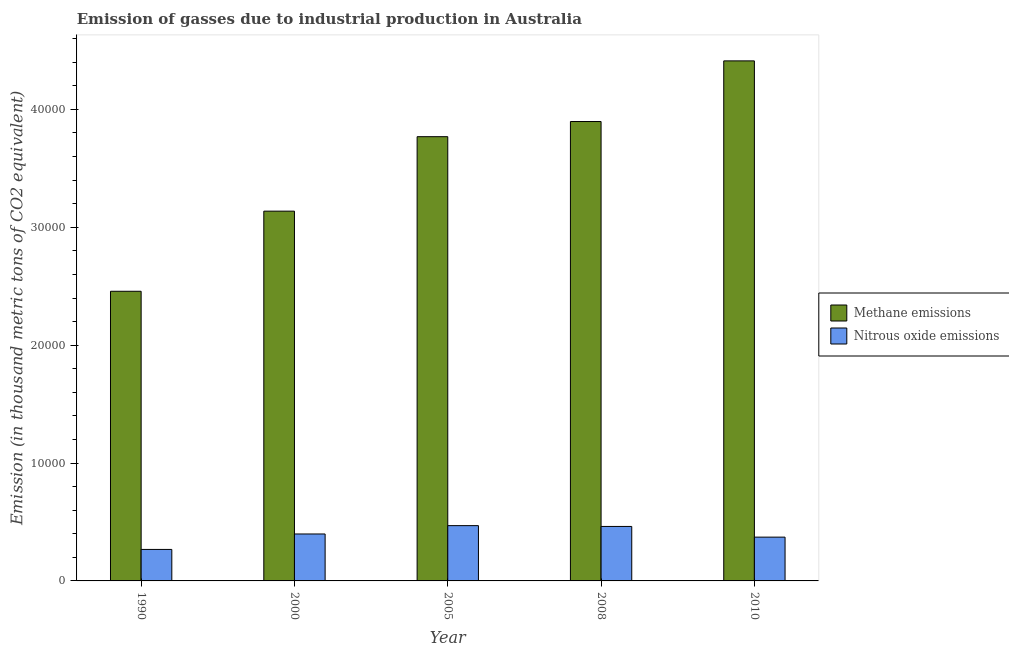How many different coloured bars are there?
Make the answer very short. 2. How many groups of bars are there?
Offer a terse response. 5. What is the label of the 3rd group of bars from the left?
Offer a terse response. 2005. In how many cases, is the number of bars for a given year not equal to the number of legend labels?
Offer a very short reply. 0. What is the amount of nitrous oxide emissions in 2008?
Your answer should be compact. 4621. Across all years, what is the maximum amount of nitrous oxide emissions?
Make the answer very short. 4690.1. Across all years, what is the minimum amount of nitrous oxide emissions?
Keep it short and to the point. 2671. In which year was the amount of nitrous oxide emissions maximum?
Provide a short and direct response. 2005. In which year was the amount of methane emissions minimum?
Give a very brief answer. 1990. What is the total amount of nitrous oxide emissions in the graph?
Offer a terse response. 1.97e+04. What is the difference between the amount of methane emissions in 1990 and that in 2010?
Provide a short and direct response. -1.95e+04. What is the difference between the amount of methane emissions in 1990 and the amount of nitrous oxide emissions in 2010?
Keep it short and to the point. -1.95e+04. What is the average amount of nitrous oxide emissions per year?
Provide a short and direct response. 3935.56. What is the ratio of the amount of nitrous oxide emissions in 1990 to that in 2010?
Make the answer very short. 0.72. Is the difference between the amount of nitrous oxide emissions in 2000 and 2005 greater than the difference between the amount of methane emissions in 2000 and 2005?
Your answer should be very brief. No. What is the difference between the highest and the second highest amount of nitrous oxide emissions?
Provide a succinct answer. 69.1. What is the difference between the highest and the lowest amount of methane emissions?
Offer a terse response. 1.95e+04. Is the sum of the amount of nitrous oxide emissions in 1990 and 2008 greater than the maximum amount of methane emissions across all years?
Keep it short and to the point. Yes. What does the 1st bar from the left in 1990 represents?
Provide a succinct answer. Methane emissions. What does the 1st bar from the right in 2005 represents?
Your response must be concise. Nitrous oxide emissions. How many years are there in the graph?
Give a very brief answer. 5. What is the difference between two consecutive major ticks on the Y-axis?
Provide a short and direct response. 10000. Are the values on the major ticks of Y-axis written in scientific E-notation?
Provide a short and direct response. No. Does the graph contain grids?
Provide a succinct answer. No. Where does the legend appear in the graph?
Your response must be concise. Center right. How many legend labels are there?
Make the answer very short. 2. How are the legend labels stacked?
Offer a very short reply. Vertical. What is the title of the graph?
Make the answer very short. Emission of gasses due to industrial production in Australia. What is the label or title of the Y-axis?
Provide a short and direct response. Emission (in thousand metric tons of CO2 equivalent). What is the Emission (in thousand metric tons of CO2 equivalent) in Methane emissions in 1990?
Offer a very short reply. 2.46e+04. What is the Emission (in thousand metric tons of CO2 equivalent) in Nitrous oxide emissions in 1990?
Ensure brevity in your answer.  2671. What is the Emission (in thousand metric tons of CO2 equivalent) of Methane emissions in 2000?
Offer a terse response. 3.14e+04. What is the Emission (in thousand metric tons of CO2 equivalent) of Nitrous oxide emissions in 2000?
Make the answer very short. 3981.7. What is the Emission (in thousand metric tons of CO2 equivalent) in Methane emissions in 2005?
Your answer should be compact. 3.77e+04. What is the Emission (in thousand metric tons of CO2 equivalent) in Nitrous oxide emissions in 2005?
Offer a very short reply. 4690.1. What is the Emission (in thousand metric tons of CO2 equivalent) of Methane emissions in 2008?
Offer a very short reply. 3.90e+04. What is the Emission (in thousand metric tons of CO2 equivalent) of Nitrous oxide emissions in 2008?
Your answer should be compact. 4621. What is the Emission (in thousand metric tons of CO2 equivalent) in Methane emissions in 2010?
Provide a succinct answer. 4.41e+04. What is the Emission (in thousand metric tons of CO2 equivalent) of Nitrous oxide emissions in 2010?
Your response must be concise. 3714. Across all years, what is the maximum Emission (in thousand metric tons of CO2 equivalent) of Methane emissions?
Your answer should be compact. 4.41e+04. Across all years, what is the maximum Emission (in thousand metric tons of CO2 equivalent) in Nitrous oxide emissions?
Provide a succinct answer. 4690.1. Across all years, what is the minimum Emission (in thousand metric tons of CO2 equivalent) of Methane emissions?
Provide a short and direct response. 2.46e+04. Across all years, what is the minimum Emission (in thousand metric tons of CO2 equivalent) in Nitrous oxide emissions?
Make the answer very short. 2671. What is the total Emission (in thousand metric tons of CO2 equivalent) in Methane emissions in the graph?
Provide a succinct answer. 1.77e+05. What is the total Emission (in thousand metric tons of CO2 equivalent) in Nitrous oxide emissions in the graph?
Keep it short and to the point. 1.97e+04. What is the difference between the Emission (in thousand metric tons of CO2 equivalent) of Methane emissions in 1990 and that in 2000?
Your answer should be compact. -6797.8. What is the difference between the Emission (in thousand metric tons of CO2 equivalent) in Nitrous oxide emissions in 1990 and that in 2000?
Your answer should be very brief. -1310.7. What is the difference between the Emission (in thousand metric tons of CO2 equivalent) in Methane emissions in 1990 and that in 2005?
Provide a succinct answer. -1.31e+04. What is the difference between the Emission (in thousand metric tons of CO2 equivalent) of Nitrous oxide emissions in 1990 and that in 2005?
Your response must be concise. -2019.1. What is the difference between the Emission (in thousand metric tons of CO2 equivalent) in Methane emissions in 1990 and that in 2008?
Your answer should be very brief. -1.44e+04. What is the difference between the Emission (in thousand metric tons of CO2 equivalent) of Nitrous oxide emissions in 1990 and that in 2008?
Your answer should be compact. -1950. What is the difference between the Emission (in thousand metric tons of CO2 equivalent) in Methane emissions in 1990 and that in 2010?
Your answer should be very brief. -1.95e+04. What is the difference between the Emission (in thousand metric tons of CO2 equivalent) in Nitrous oxide emissions in 1990 and that in 2010?
Provide a short and direct response. -1043. What is the difference between the Emission (in thousand metric tons of CO2 equivalent) in Methane emissions in 2000 and that in 2005?
Provide a succinct answer. -6316.4. What is the difference between the Emission (in thousand metric tons of CO2 equivalent) in Nitrous oxide emissions in 2000 and that in 2005?
Make the answer very short. -708.4. What is the difference between the Emission (in thousand metric tons of CO2 equivalent) of Methane emissions in 2000 and that in 2008?
Offer a terse response. -7602.4. What is the difference between the Emission (in thousand metric tons of CO2 equivalent) of Nitrous oxide emissions in 2000 and that in 2008?
Provide a short and direct response. -639.3. What is the difference between the Emission (in thousand metric tons of CO2 equivalent) of Methane emissions in 2000 and that in 2010?
Provide a short and direct response. -1.27e+04. What is the difference between the Emission (in thousand metric tons of CO2 equivalent) of Nitrous oxide emissions in 2000 and that in 2010?
Offer a terse response. 267.7. What is the difference between the Emission (in thousand metric tons of CO2 equivalent) of Methane emissions in 2005 and that in 2008?
Keep it short and to the point. -1286. What is the difference between the Emission (in thousand metric tons of CO2 equivalent) of Nitrous oxide emissions in 2005 and that in 2008?
Keep it short and to the point. 69.1. What is the difference between the Emission (in thousand metric tons of CO2 equivalent) of Methane emissions in 2005 and that in 2010?
Provide a succinct answer. -6430.6. What is the difference between the Emission (in thousand metric tons of CO2 equivalent) in Nitrous oxide emissions in 2005 and that in 2010?
Make the answer very short. 976.1. What is the difference between the Emission (in thousand metric tons of CO2 equivalent) of Methane emissions in 2008 and that in 2010?
Offer a terse response. -5144.6. What is the difference between the Emission (in thousand metric tons of CO2 equivalent) of Nitrous oxide emissions in 2008 and that in 2010?
Your answer should be compact. 907. What is the difference between the Emission (in thousand metric tons of CO2 equivalent) in Methane emissions in 1990 and the Emission (in thousand metric tons of CO2 equivalent) in Nitrous oxide emissions in 2000?
Provide a short and direct response. 2.06e+04. What is the difference between the Emission (in thousand metric tons of CO2 equivalent) in Methane emissions in 1990 and the Emission (in thousand metric tons of CO2 equivalent) in Nitrous oxide emissions in 2005?
Keep it short and to the point. 1.99e+04. What is the difference between the Emission (in thousand metric tons of CO2 equivalent) of Methane emissions in 1990 and the Emission (in thousand metric tons of CO2 equivalent) of Nitrous oxide emissions in 2008?
Your answer should be compact. 1.99e+04. What is the difference between the Emission (in thousand metric tons of CO2 equivalent) of Methane emissions in 1990 and the Emission (in thousand metric tons of CO2 equivalent) of Nitrous oxide emissions in 2010?
Offer a very short reply. 2.09e+04. What is the difference between the Emission (in thousand metric tons of CO2 equivalent) of Methane emissions in 2000 and the Emission (in thousand metric tons of CO2 equivalent) of Nitrous oxide emissions in 2005?
Ensure brevity in your answer.  2.67e+04. What is the difference between the Emission (in thousand metric tons of CO2 equivalent) of Methane emissions in 2000 and the Emission (in thousand metric tons of CO2 equivalent) of Nitrous oxide emissions in 2008?
Your answer should be compact. 2.67e+04. What is the difference between the Emission (in thousand metric tons of CO2 equivalent) of Methane emissions in 2000 and the Emission (in thousand metric tons of CO2 equivalent) of Nitrous oxide emissions in 2010?
Ensure brevity in your answer.  2.77e+04. What is the difference between the Emission (in thousand metric tons of CO2 equivalent) in Methane emissions in 2005 and the Emission (in thousand metric tons of CO2 equivalent) in Nitrous oxide emissions in 2008?
Provide a succinct answer. 3.31e+04. What is the difference between the Emission (in thousand metric tons of CO2 equivalent) in Methane emissions in 2005 and the Emission (in thousand metric tons of CO2 equivalent) in Nitrous oxide emissions in 2010?
Your answer should be compact. 3.40e+04. What is the difference between the Emission (in thousand metric tons of CO2 equivalent) in Methane emissions in 2008 and the Emission (in thousand metric tons of CO2 equivalent) in Nitrous oxide emissions in 2010?
Offer a very short reply. 3.53e+04. What is the average Emission (in thousand metric tons of CO2 equivalent) in Methane emissions per year?
Provide a succinct answer. 3.53e+04. What is the average Emission (in thousand metric tons of CO2 equivalent) in Nitrous oxide emissions per year?
Keep it short and to the point. 3935.56. In the year 1990, what is the difference between the Emission (in thousand metric tons of CO2 equivalent) in Methane emissions and Emission (in thousand metric tons of CO2 equivalent) in Nitrous oxide emissions?
Provide a succinct answer. 2.19e+04. In the year 2000, what is the difference between the Emission (in thousand metric tons of CO2 equivalent) of Methane emissions and Emission (in thousand metric tons of CO2 equivalent) of Nitrous oxide emissions?
Provide a short and direct response. 2.74e+04. In the year 2005, what is the difference between the Emission (in thousand metric tons of CO2 equivalent) of Methane emissions and Emission (in thousand metric tons of CO2 equivalent) of Nitrous oxide emissions?
Provide a short and direct response. 3.30e+04. In the year 2008, what is the difference between the Emission (in thousand metric tons of CO2 equivalent) of Methane emissions and Emission (in thousand metric tons of CO2 equivalent) of Nitrous oxide emissions?
Ensure brevity in your answer.  3.43e+04. In the year 2010, what is the difference between the Emission (in thousand metric tons of CO2 equivalent) in Methane emissions and Emission (in thousand metric tons of CO2 equivalent) in Nitrous oxide emissions?
Keep it short and to the point. 4.04e+04. What is the ratio of the Emission (in thousand metric tons of CO2 equivalent) of Methane emissions in 1990 to that in 2000?
Provide a succinct answer. 0.78. What is the ratio of the Emission (in thousand metric tons of CO2 equivalent) of Nitrous oxide emissions in 1990 to that in 2000?
Keep it short and to the point. 0.67. What is the ratio of the Emission (in thousand metric tons of CO2 equivalent) of Methane emissions in 1990 to that in 2005?
Make the answer very short. 0.65. What is the ratio of the Emission (in thousand metric tons of CO2 equivalent) in Nitrous oxide emissions in 1990 to that in 2005?
Provide a succinct answer. 0.57. What is the ratio of the Emission (in thousand metric tons of CO2 equivalent) in Methane emissions in 1990 to that in 2008?
Provide a succinct answer. 0.63. What is the ratio of the Emission (in thousand metric tons of CO2 equivalent) of Nitrous oxide emissions in 1990 to that in 2008?
Ensure brevity in your answer.  0.58. What is the ratio of the Emission (in thousand metric tons of CO2 equivalent) in Methane emissions in 1990 to that in 2010?
Provide a succinct answer. 0.56. What is the ratio of the Emission (in thousand metric tons of CO2 equivalent) of Nitrous oxide emissions in 1990 to that in 2010?
Your response must be concise. 0.72. What is the ratio of the Emission (in thousand metric tons of CO2 equivalent) in Methane emissions in 2000 to that in 2005?
Give a very brief answer. 0.83. What is the ratio of the Emission (in thousand metric tons of CO2 equivalent) in Nitrous oxide emissions in 2000 to that in 2005?
Your answer should be compact. 0.85. What is the ratio of the Emission (in thousand metric tons of CO2 equivalent) of Methane emissions in 2000 to that in 2008?
Your answer should be compact. 0.8. What is the ratio of the Emission (in thousand metric tons of CO2 equivalent) in Nitrous oxide emissions in 2000 to that in 2008?
Your answer should be compact. 0.86. What is the ratio of the Emission (in thousand metric tons of CO2 equivalent) in Methane emissions in 2000 to that in 2010?
Your response must be concise. 0.71. What is the ratio of the Emission (in thousand metric tons of CO2 equivalent) in Nitrous oxide emissions in 2000 to that in 2010?
Provide a succinct answer. 1.07. What is the ratio of the Emission (in thousand metric tons of CO2 equivalent) in Methane emissions in 2005 to that in 2010?
Provide a succinct answer. 0.85. What is the ratio of the Emission (in thousand metric tons of CO2 equivalent) of Nitrous oxide emissions in 2005 to that in 2010?
Provide a succinct answer. 1.26. What is the ratio of the Emission (in thousand metric tons of CO2 equivalent) of Methane emissions in 2008 to that in 2010?
Your answer should be very brief. 0.88. What is the ratio of the Emission (in thousand metric tons of CO2 equivalent) in Nitrous oxide emissions in 2008 to that in 2010?
Provide a short and direct response. 1.24. What is the difference between the highest and the second highest Emission (in thousand metric tons of CO2 equivalent) of Methane emissions?
Make the answer very short. 5144.6. What is the difference between the highest and the second highest Emission (in thousand metric tons of CO2 equivalent) of Nitrous oxide emissions?
Offer a very short reply. 69.1. What is the difference between the highest and the lowest Emission (in thousand metric tons of CO2 equivalent) in Methane emissions?
Give a very brief answer. 1.95e+04. What is the difference between the highest and the lowest Emission (in thousand metric tons of CO2 equivalent) in Nitrous oxide emissions?
Keep it short and to the point. 2019.1. 